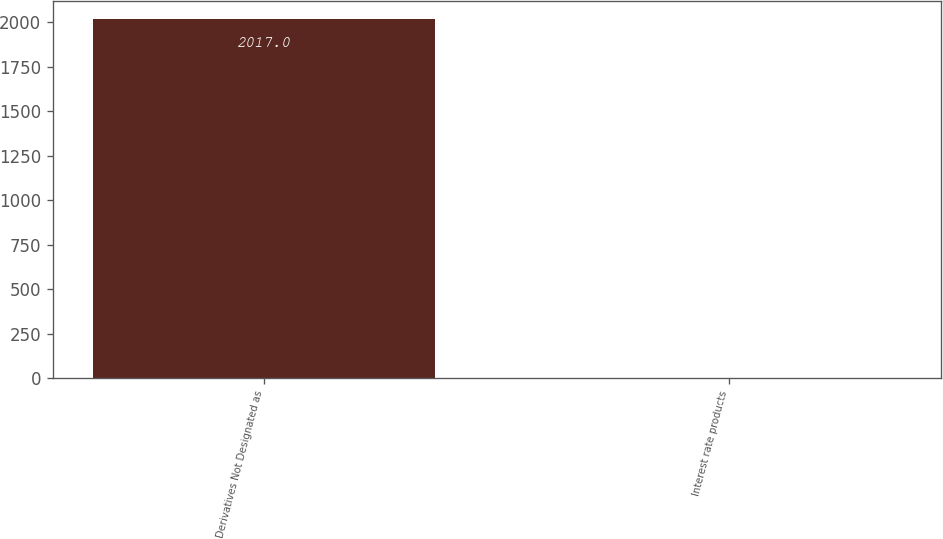Convert chart to OTSL. <chart><loc_0><loc_0><loc_500><loc_500><bar_chart><fcel>Derivatives Not Designated as<fcel>Interest rate products<nl><fcel>2017<fcel>1<nl></chart> 